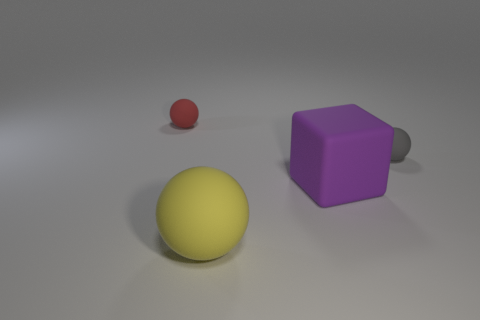Add 2 big yellow matte balls. How many objects exist? 6 Subtract all cubes. How many objects are left? 3 Subtract 0 brown spheres. How many objects are left? 4 Subtract all small metallic balls. Subtract all red rubber balls. How many objects are left? 3 Add 3 rubber objects. How many rubber objects are left? 7 Add 3 large purple rubber objects. How many large purple rubber objects exist? 4 